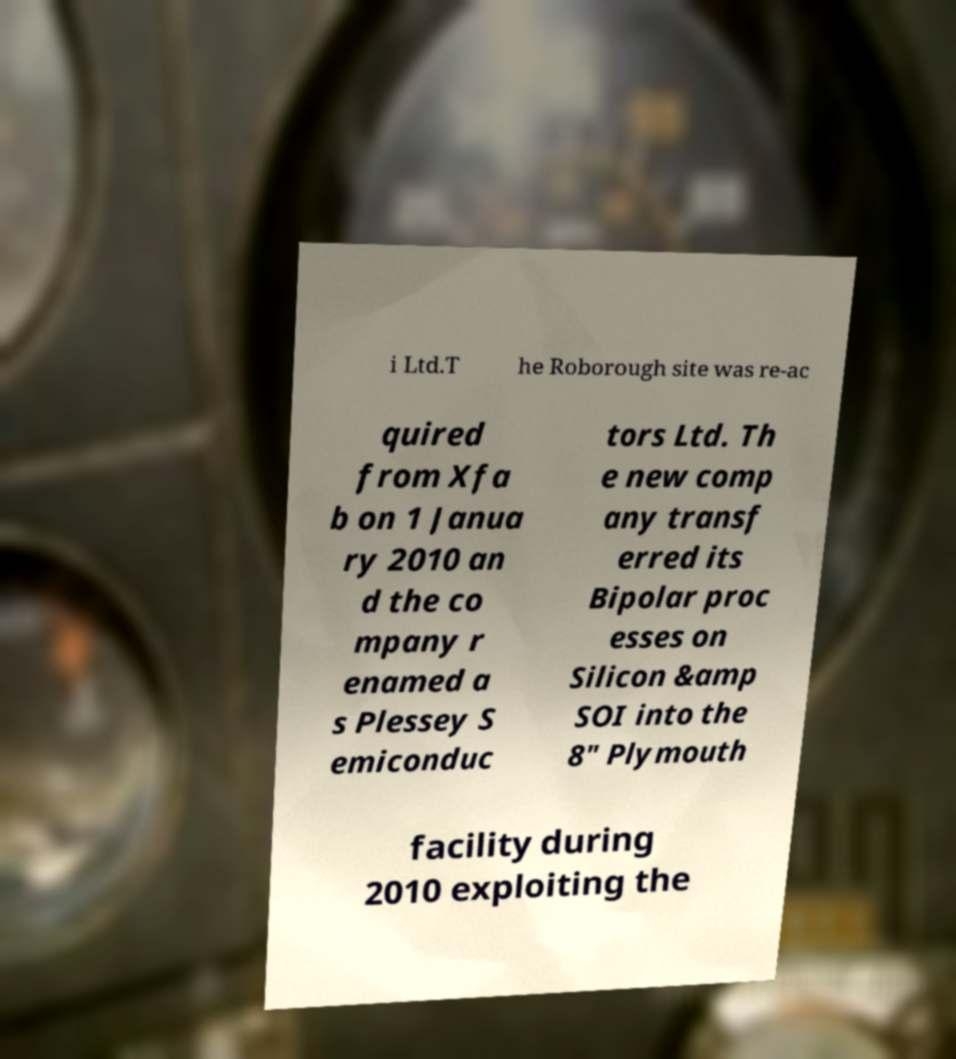For documentation purposes, I need the text within this image transcribed. Could you provide that? i Ltd.T he Roborough site was re-ac quired from Xfa b on 1 Janua ry 2010 an d the co mpany r enamed a s Plessey S emiconduc tors Ltd. Th e new comp any transf erred its Bipolar proc esses on Silicon &amp SOI into the 8" Plymouth facility during 2010 exploiting the 